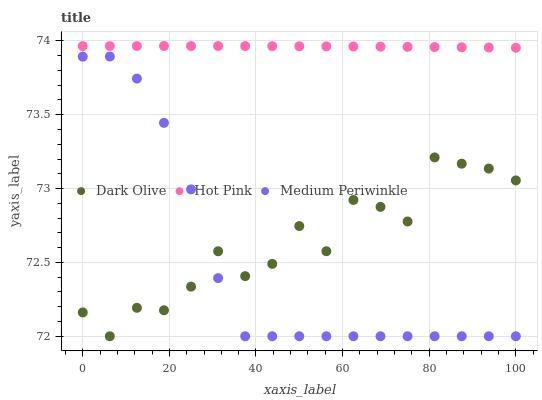Does Medium Periwinkle have the minimum area under the curve?
Answer yes or no. Yes. Does Hot Pink have the maximum area under the curve?
Answer yes or no. Yes. Does Hot Pink have the minimum area under the curve?
Answer yes or no. No. Does Medium Periwinkle have the maximum area under the curve?
Answer yes or no. No. Is Hot Pink the smoothest?
Answer yes or no. Yes. Is Dark Olive the roughest?
Answer yes or no. Yes. Is Medium Periwinkle the smoothest?
Answer yes or no. No. Is Medium Periwinkle the roughest?
Answer yes or no. No. Does Dark Olive have the lowest value?
Answer yes or no. Yes. Does Hot Pink have the lowest value?
Answer yes or no. No. Does Hot Pink have the highest value?
Answer yes or no. Yes. Does Medium Periwinkle have the highest value?
Answer yes or no. No. Is Medium Periwinkle less than Hot Pink?
Answer yes or no. Yes. Is Hot Pink greater than Medium Periwinkle?
Answer yes or no. Yes. Does Dark Olive intersect Medium Periwinkle?
Answer yes or no. Yes. Is Dark Olive less than Medium Periwinkle?
Answer yes or no. No. Is Dark Olive greater than Medium Periwinkle?
Answer yes or no. No. Does Medium Periwinkle intersect Hot Pink?
Answer yes or no. No. 